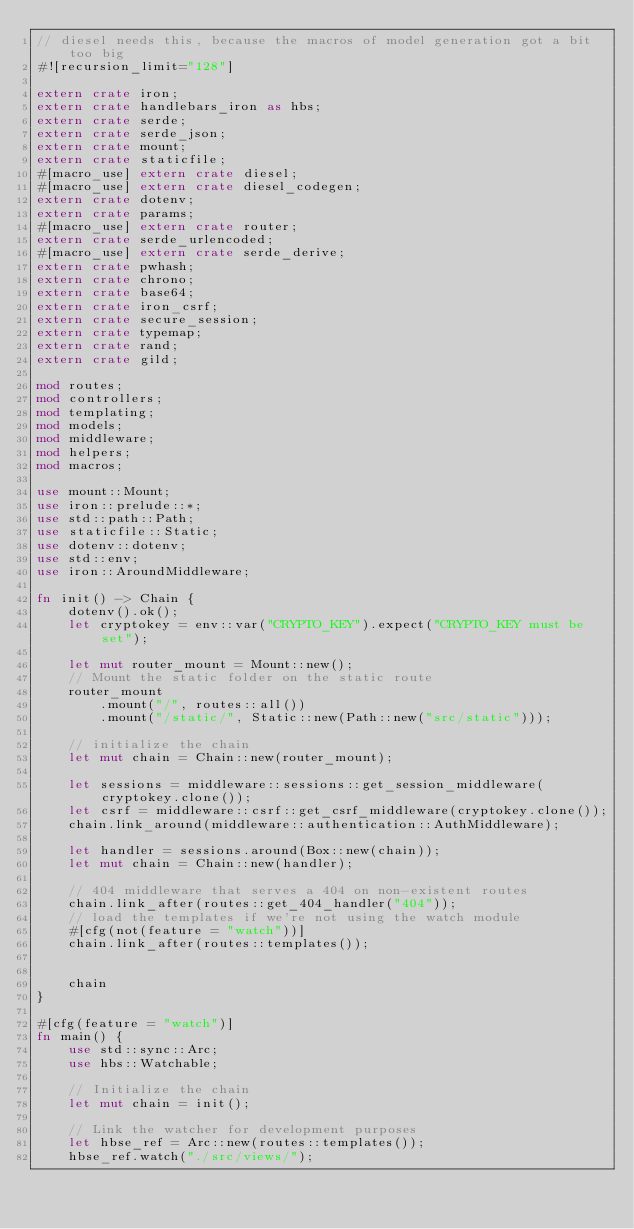Convert code to text. <code><loc_0><loc_0><loc_500><loc_500><_Rust_>// diesel needs this, because the macros of model generation got a bit too big
#![recursion_limit="128"]

extern crate iron;
extern crate handlebars_iron as hbs;
extern crate serde;
extern crate serde_json;
extern crate mount;
extern crate staticfile;
#[macro_use] extern crate diesel;
#[macro_use] extern crate diesel_codegen;
extern crate dotenv;
extern crate params;
#[macro_use] extern crate router;
extern crate serde_urlencoded;
#[macro_use] extern crate serde_derive;
extern crate pwhash;
extern crate chrono;
extern crate base64;
extern crate iron_csrf;
extern crate secure_session;
extern crate typemap;
extern crate rand;
extern crate gild;

mod routes;
mod controllers;
mod templating;
mod models;
mod middleware;
mod helpers;
mod macros;

use mount::Mount;
use iron::prelude::*;
use std::path::Path;
use staticfile::Static;
use dotenv::dotenv;
use std::env;
use iron::AroundMiddleware;

fn init() -> Chain {
    dotenv().ok();
    let cryptokey = env::var("CRYPTO_KEY").expect("CRYPTO_KEY must be set");

    let mut router_mount = Mount::new();
    // Mount the static folder on the static route
    router_mount
        .mount("/", routes::all())
        .mount("/static/", Static::new(Path::new("src/static")));

    // initialize the chain
    let mut chain = Chain::new(router_mount);

    let sessions = middleware::sessions::get_session_middleware(cryptokey.clone());
    let csrf = middleware::csrf::get_csrf_middleware(cryptokey.clone());
    chain.link_around(middleware::authentication::AuthMiddleware);

    let handler = sessions.around(Box::new(chain));
    let mut chain = Chain::new(handler);

    // 404 middleware that serves a 404 on non-existent routes
    chain.link_after(routes::get_404_handler("404"));
    // load the templates if we're not using the watch module
    #[cfg(not(feature = "watch"))]
    chain.link_after(routes::templates());


    chain
}

#[cfg(feature = "watch")]
fn main() {
    use std::sync::Arc;
    use hbs::Watchable;

    // Initialize the chain
    let mut chain = init();

    // Link the watcher for development purposes
    let hbse_ref = Arc::new(routes::templates());
    hbse_ref.watch("./src/views/");</code> 